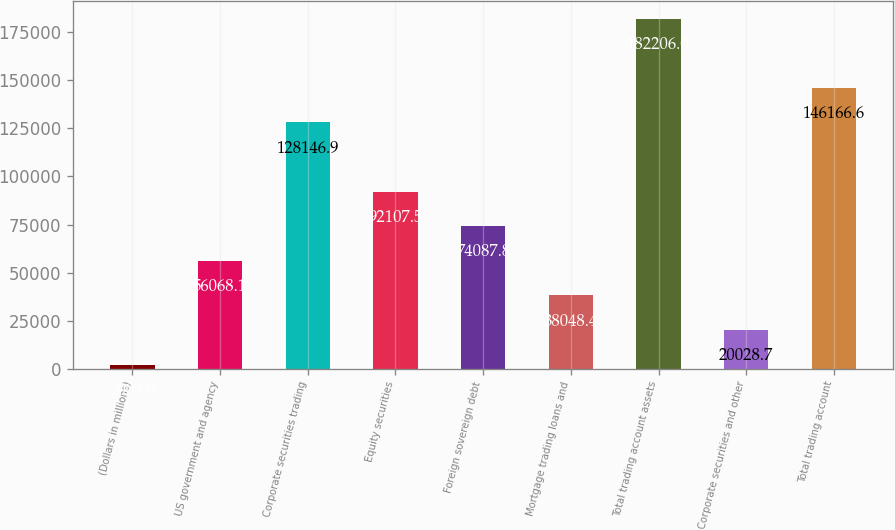Convert chart. <chart><loc_0><loc_0><loc_500><loc_500><bar_chart><fcel>(Dollars in millions)<fcel>US government and agency<fcel>Corporate securities trading<fcel>Equity securities<fcel>Foreign sovereign debt<fcel>Mortgage trading loans and<fcel>Total trading account assets<fcel>Corporate securities and other<fcel>Total trading account<nl><fcel>2009<fcel>56068.1<fcel>128147<fcel>92107.5<fcel>74087.8<fcel>38048.4<fcel>182206<fcel>20028.7<fcel>146167<nl></chart> 